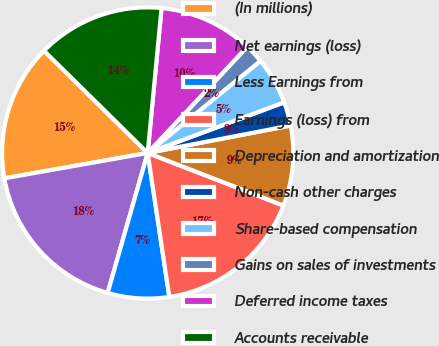Convert chart to OTSL. <chart><loc_0><loc_0><loc_500><loc_500><pie_chart><fcel>(In millions)<fcel>Net earnings (loss)<fcel>Less Earnings from<fcel>Earnings (loss) from<fcel>Depreciation and amortization<fcel>Non-cash other charges<fcel>Share-based compensation<fcel>Gains on sales of investments<fcel>Deferred income taxes<fcel>Accounts receivable<nl><fcel>15.17%<fcel>17.78%<fcel>6.81%<fcel>16.74%<fcel>8.9%<fcel>2.63%<fcel>5.25%<fcel>2.11%<fcel>10.47%<fcel>14.13%<nl></chart> 